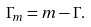<formula> <loc_0><loc_0><loc_500><loc_500>\Gamma _ { m } = m - \Gamma .</formula> 